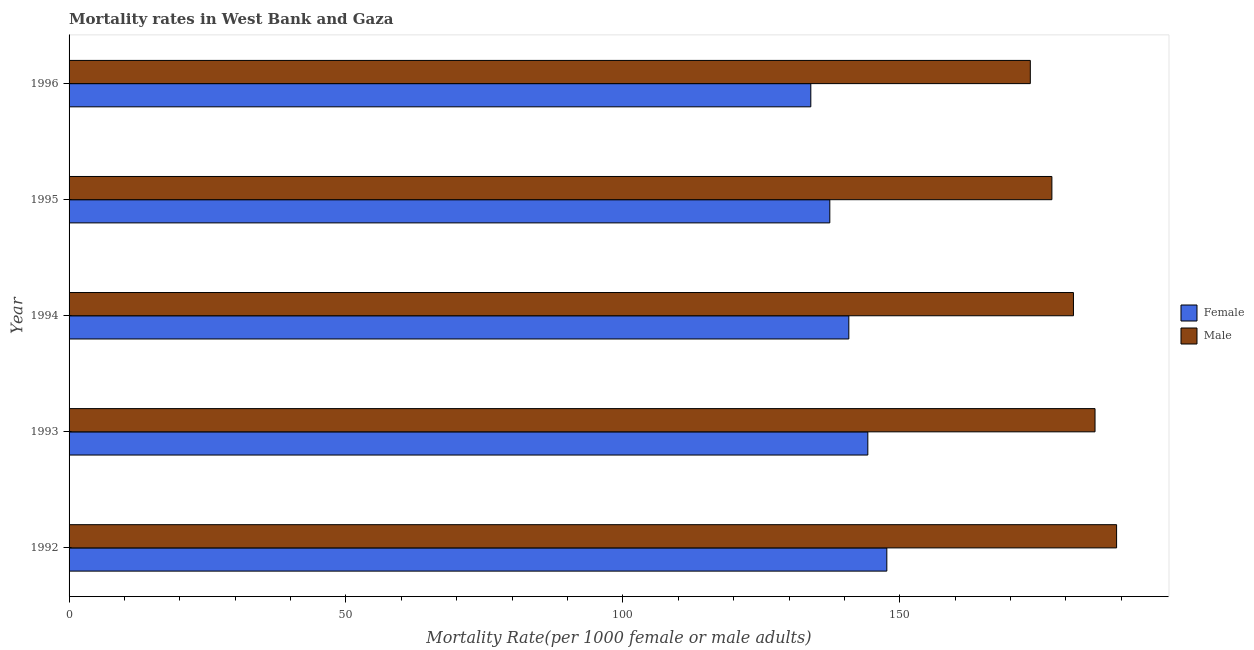How many different coloured bars are there?
Give a very brief answer. 2. Are the number of bars per tick equal to the number of legend labels?
Provide a succinct answer. Yes. In how many cases, is the number of bars for a given year not equal to the number of legend labels?
Offer a terse response. 0. What is the male mortality rate in 1993?
Ensure brevity in your answer.  185.25. Across all years, what is the maximum male mortality rate?
Your response must be concise. 189.15. Across all years, what is the minimum male mortality rate?
Make the answer very short. 173.57. In which year was the male mortality rate maximum?
Offer a terse response. 1992. In which year was the male mortality rate minimum?
Your response must be concise. 1996. What is the total male mortality rate in the graph?
Ensure brevity in your answer.  906.79. What is the difference between the male mortality rate in 1992 and that in 1993?
Your answer should be compact. 3.9. What is the difference between the female mortality rate in 1995 and the male mortality rate in 1996?
Ensure brevity in your answer.  -36.2. What is the average male mortality rate per year?
Offer a terse response. 181.36. In the year 1996, what is the difference between the female mortality rate and male mortality rate?
Keep it short and to the point. -39.63. In how many years, is the female mortality rate greater than 30 ?
Your answer should be very brief. 5. Is the male mortality rate in 1993 less than that in 1996?
Your response must be concise. No. What is the difference between the highest and the second highest male mortality rate?
Provide a succinct answer. 3.9. What is the difference between the highest and the lowest male mortality rate?
Your answer should be compact. 15.58. In how many years, is the female mortality rate greater than the average female mortality rate taken over all years?
Provide a short and direct response. 3. What does the 2nd bar from the top in 1993 represents?
Offer a very short reply. Female. What does the 2nd bar from the bottom in 1993 represents?
Offer a terse response. Male. Are the values on the major ticks of X-axis written in scientific E-notation?
Keep it short and to the point. No. Does the graph contain grids?
Provide a succinct answer. No. Where does the legend appear in the graph?
Make the answer very short. Center right. How many legend labels are there?
Provide a short and direct response. 2. How are the legend labels stacked?
Provide a succinct answer. Vertical. What is the title of the graph?
Your answer should be compact. Mortality rates in West Bank and Gaza. What is the label or title of the X-axis?
Make the answer very short. Mortality Rate(per 1000 female or male adults). What is the Mortality Rate(per 1000 female or male adults) in Female in 1992?
Offer a terse response. 147.66. What is the Mortality Rate(per 1000 female or male adults) in Male in 1992?
Keep it short and to the point. 189.15. What is the Mortality Rate(per 1000 female or male adults) of Female in 1993?
Offer a terse response. 144.23. What is the Mortality Rate(per 1000 female or male adults) in Male in 1993?
Offer a very short reply. 185.25. What is the Mortality Rate(per 1000 female or male adults) in Female in 1994?
Make the answer very short. 140.8. What is the Mortality Rate(per 1000 female or male adults) in Male in 1994?
Your answer should be compact. 181.36. What is the Mortality Rate(per 1000 female or male adults) in Female in 1995?
Give a very brief answer. 137.36. What is the Mortality Rate(per 1000 female or male adults) in Male in 1995?
Your answer should be very brief. 177.46. What is the Mortality Rate(per 1000 female or male adults) of Female in 1996?
Make the answer very short. 133.93. What is the Mortality Rate(per 1000 female or male adults) of Male in 1996?
Give a very brief answer. 173.57. Across all years, what is the maximum Mortality Rate(per 1000 female or male adults) of Female?
Make the answer very short. 147.66. Across all years, what is the maximum Mortality Rate(per 1000 female or male adults) in Male?
Make the answer very short. 189.15. Across all years, what is the minimum Mortality Rate(per 1000 female or male adults) in Female?
Offer a terse response. 133.93. Across all years, what is the minimum Mortality Rate(per 1000 female or male adults) of Male?
Your answer should be very brief. 173.57. What is the total Mortality Rate(per 1000 female or male adults) in Female in the graph?
Your answer should be compact. 703.98. What is the total Mortality Rate(per 1000 female or male adults) of Male in the graph?
Your response must be concise. 906.79. What is the difference between the Mortality Rate(per 1000 female or male adults) in Female in 1992 and that in 1993?
Ensure brevity in your answer.  3.43. What is the difference between the Mortality Rate(per 1000 female or male adults) in Male in 1992 and that in 1993?
Your response must be concise. 3.89. What is the difference between the Mortality Rate(per 1000 female or male adults) in Female in 1992 and that in 1994?
Offer a terse response. 6.86. What is the difference between the Mortality Rate(per 1000 female or male adults) of Male in 1992 and that in 1994?
Offer a very short reply. 7.79. What is the difference between the Mortality Rate(per 1000 female or male adults) in Female in 1992 and that in 1995?
Provide a short and direct response. 10.29. What is the difference between the Mortality Rate(per 1000 female or male adults) in Male in 1992 and that in 1995?
Your response must be concise. 11.68. What is the difference between the Mortality Rate(per 1000 female or male adults) in Female in 1992 and that in 1996?
Keep it short and to the point. 13.72. What is the difference between the Mortality Rate(per 1000 female or male adults) of Male in 1992 and that in 1996?
Provide a short and direct response. 15.58. What is the difference between the Mortality Rate(per 1000 female or male adults) in Female in 1993 and that in 1994?
Your answer should be very brief. 3.43. What is the difference between the Mortality Rate(per 1000 female or male adults) of Male in 1993 and that in 1994?
Your answer should be very brief. 3.89. What is the difference between the Mortality Rate(per 1000 female or male adults) of Female in 1993 and that in 1995?
Your answer should be compact. 6.86. What is the difference between the Mortality Rate(per 1000 female or male adults) of Male in 1993 and that in 1995?
Make the answer very short. 7.79. What is the difference between the Mortality Rate(per 1000 female or male adults) in Female in 1993 and that in 1996?
Make the answer very short. 10.29. What is the difference between the Mortality Rate(per 1000 female or male adults) of Male in 1993 and that in 1996?
Make the answer very short. 11.68. What is the difference between the Mortality Rate(per 1000 female or male adults) of Female in 1994 and that in 1995?
Your response must be concise. 3.43. What is the difference between the Mortality Rate(per 1000 female or male adults) in Male in 1994 and that in 1995?
Provide a succinct answer. 3.89. What is the difference between the Mortality Rate(per 1000 female or male adults) in Female in 1994 and that in 1996?
Ensure brevity in your answer.  6.86. What is the difference between the Mortality Rate(per 1000 female or male adults) of Male in 1994 and that in 1996?
Offer a very short reply. 7.79. What is the difference between the Mortality Rate(per 1000 female or male adults) in Female in 1995 and that in 1996?
Ensure brevity in your answer.  3.43. What is the difference between the Mortality Rate(per 1000 female or male adults) of Male in 1995 and that in 1996?
Your answer should be very brief. 3.89. What is the difference between the Mortality Rate(per 1000 female or male adults) of Female in 1992 and the Mortality Rate(per 1000 female or male adults) of Male in 1993?
Offer a terse response. -37.59. What is the difference between the Mortality Rate(per 1000 female or male adults) of Female in 1992 and the Mortality Rate(per 1000 female or male adults) of Male in 1994?
Your answer should be compact. -33.7. What is the difference between the Mortality Rate(per 1000 female or male adults) in Female in 1992 and the Mortality Rate(per 1000 female or male adults) in Male in 1995?
Offer a terse response. -29.8. What is the difference between the Mortality Rate(per 1000 female or male adults) of Female in 1992 and the Mortality Rate(per 1000 female or male adults) of Male in 1996?
Your answer should be very brief. -25.91. What is the difference between the Mortality Rate(per 1000 female or male adults) of Female in 1993 and the Mortality Rate(per 1000 female or male adults) of Male in 1994?
Give a very brief answer. -37.13. What is the difference between the Mortality Rate(per 1000 female or male adults) of Female in 1993 and the Mortality Rate(per 1000 female or male adults) of Male in 1995?
Keep it short and to the point. -33.24. What is the difference between the Mortality Rate(per 1000 female or male adults) of Female in 1993 and the Mortality Rate(per 1000 female or male adults) of Male in 1996?
Your answer should be very brief. -29.34. What is the difference between the Mortality Rate(per 1000 female or male adults) of Female in 1994 and the Mortality Rate(per 1000 female or male adults) of Male in 1995?
Offer a terse response. -36.67. What is the difference between the Mortality Rate(per 1000 female or male adults) of Female in 1994 and the Mortality Rate(per 1000 female or male adults) of Male in 1996?
Your response must be concise. -32.77. What is the difference between the Mortality Rate(per 1000 female or male adults) in Female in 1995 and the Mortality Rate(per 1000 female or male adults) in Male in 1996?
Make the answer very short. -36.2. What is the average Mortality Rate(per 1000 female or male adults) of Female per year?
Offer a terse response. 140.8. What is the average Mortality Rate(per 1000 female or male adults) of Male per year?
Keep it short and to the point. 181.36. In the year 1992, what is the difference between the Mortality Rate(per 1000 female or male adults) of Female and Mortality Rate(per 1000 female or male adults) of Male?
Your answer should be compact. -41.49. In the year 1993, what is the difference between the Mortality Rate(per 1000 female or male adults) of Female and Mortality Rate(per 1000 female or male adults) of Male?
Ensure brevity in your answer.  -41.03. In the year 1994, what is the difference between the Mortality Rate(per 1000 female or male adults) of Female and Mortality Rate(per 1000 female or male adults) of Male?
Your response must be concise. -40.56. In the year 1995, what is the difference between the Mortality Rate(per 1000 female or male adults) of Female and Mortality Rate(per 1000 female or male adults) of Male?
Offer a very short reply. -40.1. In the year 1996, what is the difference between the Mortality Rate(per 1000 female or male adults) in Female and Mortality Rate(per 1000 female or male adults) in Male?
Your response must be concise. -39.63. What is the ratio of the Mortality Rate(per 1000 female or male adults) in Female in 1992 to that in 1993?
Your answer should be compact. 1.02. What is the ratio of the Mortality Rate(per 1000 female or male adults) of Female in 1992 to that in 1994?
Your answer should be compact. 1.05. What is the ratio of the Mortality Rate(per 1000 female or male adults) in Male in 1992 to that in 1994?
Offer a very short reply. 1.04. What is the ratio of the Mortality Rate(per 1000 female or male adults) in Female in 1992 to that in 1995?
Ensure brevity in your answer.  1.07. What is the ratio of the Mortality Rate(per 1000 female or male adults) in Male in 1992 to that in 1995?
Make the answer very short. 1.07. What is the ratio of the Mortality Rate(per 1000 female or male adults) in Female in 1992 to that in 1996?
Your answer should be very brief. 1.1. What is the ratio of the Mortality Rate(per 1000 female or male adults) in Male in 1992 to that in 1996?
Offer a very short reply. 1.09. What is the ratio of the Mortality Rate(per 1000 female or male adults) in Female in 1993 to that in 1994?
Offer a very short reply. 1.02. What is the ratio of the Mortality Rate(per 1000 female or male adults) of Male in 1993 to that in 1994?
Your answer should be compact. 1.02. What is the ratio of the Mortality Rate(per 1000 female or male adults) of Female in 1993 to that in 1995?
Ensure brevity in your answer.  1.05. What is the ratio of the Mortality Rate(per 1000 female or male adults) of Male in 1993 to that in 1995?
Make the answer very short. 1.04. What is the ratio of the Mortality Rate(per 1000 female or male adults) of Female in 1993 to that in 1996?
Keep it short and to the point. 1.08. What is the ratio of the Mortality Rate(per 1000 female or male adults) in Male in 1993 to that in 1996?
Your response must be concise. 1.07. What is the ratio of the Mortality Rate(per 1000 female or male adults) of Female in 1994 to that in 1995?
Ensure brevity in your answer.  1.02. What is the ratio of the Mortality Rate(per 1000 female or male adults) of Male in 1994 to that in 1995?
Your answer should be compact. 1.02. What is the ratio of the Mortality Rate(per 1000 female or male adults) in Female in 1994 to that in 1996?
Ensure brevity in your answer.  1.05. What is the ratio of the Mortality Rate(per 1000 female or male adults) in Male in 1994 to that in 1996?
Ensure brevity in your answer.  1.04. What is the ratio of the Mortality Rate(per 1000 female or male adults) of Female in 1995 to that in 1996?
Keep it short and to the point. 1.03. What is the ratio of the Mortality Rate(per 1000 female or male adults) in Male in 1995 to that in 1996?
Make the answer very short. 1.02. What is the difference between the highest and the second highest Mortality Rate(per 1000 female or male adults) of Female?
Make the answer very short. 3.43. What is the difference between the highest and the second highest Mortality Rate(per 1000 female or male adults) in Male?
Keep it short and to the point. 3.89. What is the difference between the highest and the lowest Mortality Rate(per 1000 female or male adults) of Female?
Keep it short and to the point. 13.72. What is the difference between the highest and the lowest Mortality Rate(per 1000 female or male adults) in Male?
Your answer should be very brief. 15.58. 